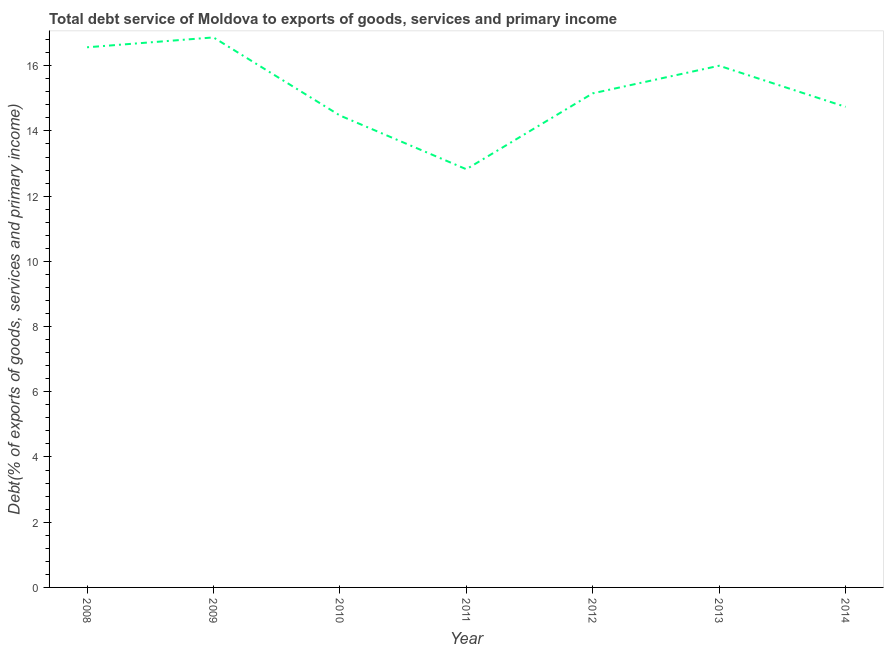What is the total debt service in 2011?
Offer a very short reply. 12.83. Across all years, what is the maximum total debt service?
Offer a very short reply. 16.87. Across all years, what is the minimum total debt service?
Offer a terse response. 12.83. In which year was the total debt service minimum?
Ensure brevity in your answer.  2011. What is the sum of the total debt service?
Give a very brief answer. 106.62. What is the difference between the total debt service in 2012 and 2013?
Offer a very short reply. -0.85. What is the average total debt service per year?
Your answer should be compact. 15.23. What is the median total debt service?
Provide a short and direct response. 15.15. In how many years, is the total debt service greater than 12.4 %?
Ensure brevity in your answer.  7. What is the ratio of the total debt service in 2008 to that in 2012?
Your response must be concise. 1.09. What is the difference between the highest and the second highest total debt service?
Offer a very short reply. 0.3. What is the difference between the highest and the lowest total debt service?
Offer a very short reply. 4.04. In how many years, is the total debt service greater than the average total debt service taken over all years?
Give a very brief answer. 3. What is the difference between two consecutive major ticks on the Y-axis?
Offer a very short reply. 2. Are the values on the major ticks of Y-axis written in scientific E-notation?
Provide a succinct answer. No. What is the title of the graph?
Your answer should be very brief. Total debt service of Moldova to exports of goods, services and primary income. What is the label or title of the X-axis?
Provide a succinct answer. Year. What is the label or title of the Y-axis?
Ensure brevity in your answer.  Debt(% of exports of goods, services and primary income). What is the Debt(% of exports of goods, services and primary income) in 2008?
Provide a succinct answer. 16.56. What is the Debt(% of exports of goods, services and primary income) in 2009?
Offer a terse response. 16.87. What is the Debt(% of exports of goods, services and primary income) of 2010?
Your answer should be compact. 14.47. What is the Debt(% of exports of goods, services and primary income) of 2011?
Your response must be concise. 12.83. What is the Debt(% of exports of goods, services and primary income) of 2012?
Keep it short and to the point. 15.15. What is the Debt(% of exports of goods, services and primary income) in 2013?
Ensure brevity in your answer.  16. What is the Debt(% of exports of goods, services and primary income) in 2014?
Your answer should be compact. 14.74. What is the difference between the Debt(% of exports of goods, services and primary income) in 2008 and 2009?
Ensure brevity in your answer.  -0.3. What is the difference between the Debt(% of exports of goods, services and primary income) in 2008 and 2010?
Your answer should be compact. 2.09. What is the difference between the Debt(% of exports of goods, services and primary income) in 2008 and 2011?
Your response must be concise. 3.74. What is the difference between the Debt(% of exports of goods, services and primary income) in 2008 and 2012?
Your answer should be compact. 1.41. What is the difference between the Debt(% of exports of goods, services and primary income) in 2008 and 2013?
Your answer should be compact. 0.57. What is the difference between the Debt(% of exports of goods, services and primary income) in 2008 and 2014?
Make the answer very short. 1.83. What is the difference between the Debt(% of exports of goods, services and primary income) in 2009 and 2010?
Provide a short and direct response. 2.39. What is the difference between the Debt(% of exports of goods, services and primary income) in 2009 and 2011?
Your response must be concise. 4.04. What is the difference between the Debt(% of exports of goods, services and primary income) in 2009 and 2012?
Your answer should be very brief. 1.71. What is the difference between the Debt(% of exports of goods, services and primary income) in 2009 and 2013?
Your answer should be compact. 0.87. What is the difference between the Debt(% of exports of goods, services and primary income) in 2009 and 2014?
Offer a terse response. 2.13. What is the difference between the Debt(% of exports of goods, services and primary income) in 2010 and 2011?
Keep it short and to the point. 1.65. What is the difference between the Debt(% of exports of goods, services and primary income) in 2010 and 2012?
Give a very brief answer. -0.68. What is the difference between the Debt(% of exports of goods, services and primary income) in 2010 and 2013?
Your answer should be compact. -1.53. What is the difference between the Debt(% of exports of goods, services and primary income) in 2010 and 2014?
Keep it short and to the point. -0.27. What is the difference between the Debt(% of exports of goods, services and primary income) in 2011 and 2012?
Your answer should be very brief. -2.33. What is the difference between the Debt(% of exports of goods, services and primary income) in 2011 and 2013?
Ensure brevity in your answer.  -3.17. What is the difference between the Debt(% of exports of goods, services and primary income) in 2011 and 2014?
Your answer should be very brief. -1.91. What is the difference between the Debt(% of exports of goods, services and primary income) in 2012 and 2013?
Provide a succinct answer. -0.85. What is the difference between the Debt(% of exports of goods, services and primary income) in 2012 and 2014?
Provide a short and direct response. 0.41. What is the difference between the Debt(% of exports of goods, services and primary income) in 2013 and 2014?
Ensure brevity in your answer.  1.26. What is the ratio of the Debt(% of exports of goods, services and primary income) in 2008 to that in 2009?
Your answer should be compact. 0.98. What is the ratio of the Debt(% of exports of goods, services and primary income) in 2008 to that in 2010?
Make the answer very short. 1.15. What is the ratio of the Debt(% of exports of goods, services and primary income) in 2008 to that in 2011?
Your response must be concise. 1.29. What is the ratio of the Debt(% of exports of goods, services and primary income) in 2008 to that in 2012?
Your answer should be compact. 1.09. What is the ratio of the Debt(% of exports of goods, services and primary income) in 2008 to that in 2013?
Your response must be concise. 1.03. What is the ratio of the Debt(% of exports of goods, services and primary income) in 2008 to that in 2014?
Provide a short and direct response. 1.12. What is the ratio of the Debt(% of exports of goods, services and primary income) in 2009 to that in 2010?
Make the answer very short. 1.17. What is the ratio of the Debt(% of exports of goods, services and primary income) in 2009 to that in 2011?
Ensure brevity in your answer.  1.31. What is the ratio of the Debt(% of exports of goods, services and primary income) in 2009 to that in 2012?
Give a very brief answer. 1.11. What is the ratio of the Debt(% of exports of goods, services and primary income) in 2009 to that in 2013?
Give a very brief answer. 1.05. What is the ratio of the Debt(% of exports of goods, services and primary income) in 2009 to that in 2014?
Your response must be concise. 1.14. What is the ratio of the Debt(% of exports of goods, services and primary income) in 2010 to that in 2011?
Keep it short and to the point. 1.13. What is the ratio of the Debt(% of exports of goods, services and primary income) in 2010 to that in 2012?
Provide a short and direct response. 0.95. What is the ratio of the Debt(% of exports of goods, services and primary income) in 2010 to that in 2013?
Ensure brevity in your answer.  0.91. What is the ratio of the Debt(% of exports of goods, services and primary income) in 2011 to that in 2012?
Your answer should be very brief. 0.85. What is the ratio of the Debt(% of exports of goods, services and primary income) in 2011 to that in 2013?
Make the answer very short. 0.8. What is the ratio of the Debt(% of exports of goods, services and primary income) in 2011 to that in 2014?
Offer a very short reply. 0.87. What is the ratio of the Debt(% of exports of goods, services and primary income) in 2012 to that in 2013?
Give a very brief answer. 0.95. What is the ratio of the Debt(% of exports of goods, services and primary income) in 2012 to that in 2014?
Your answer should be very brief. 1.03. What is the ratio of the Debt(% of exports of goods, services and primary income) in 2013 to that in 2014?
Make the answer very short. 1.09. 